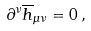<formula> <loc_0><loc_0><loc_500><loc_500>\partial ^ { \nu } { \overline { h } } _ { \mu \nu } = 0 \, ,</formula> 